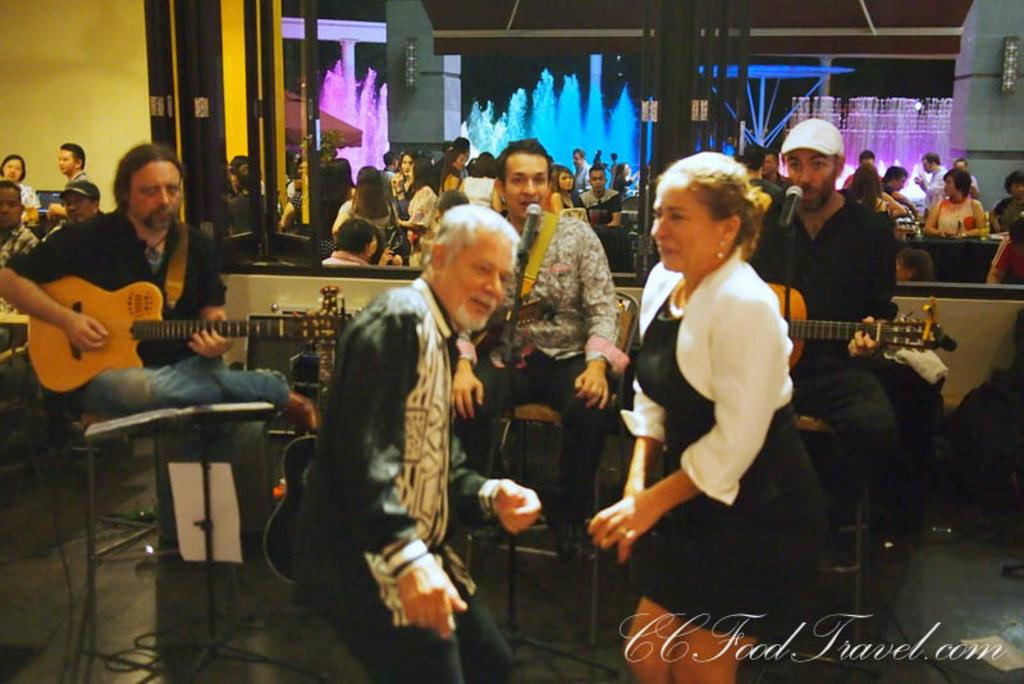What are the persons in the image doing? They are sitting on chairs and playing a guitar. Is there any vocal accompaniment? Yes, one person is singing on a microphone. What is the setting of the image? There is a floor and a wall in the image. Are there any additional features in the room? Yes, there are lights in the image. What type of bean is being used as a prop in the image? There is no bean present in the image. Can you describe the behavior of the robin in the image? There is no robin present in the image. 